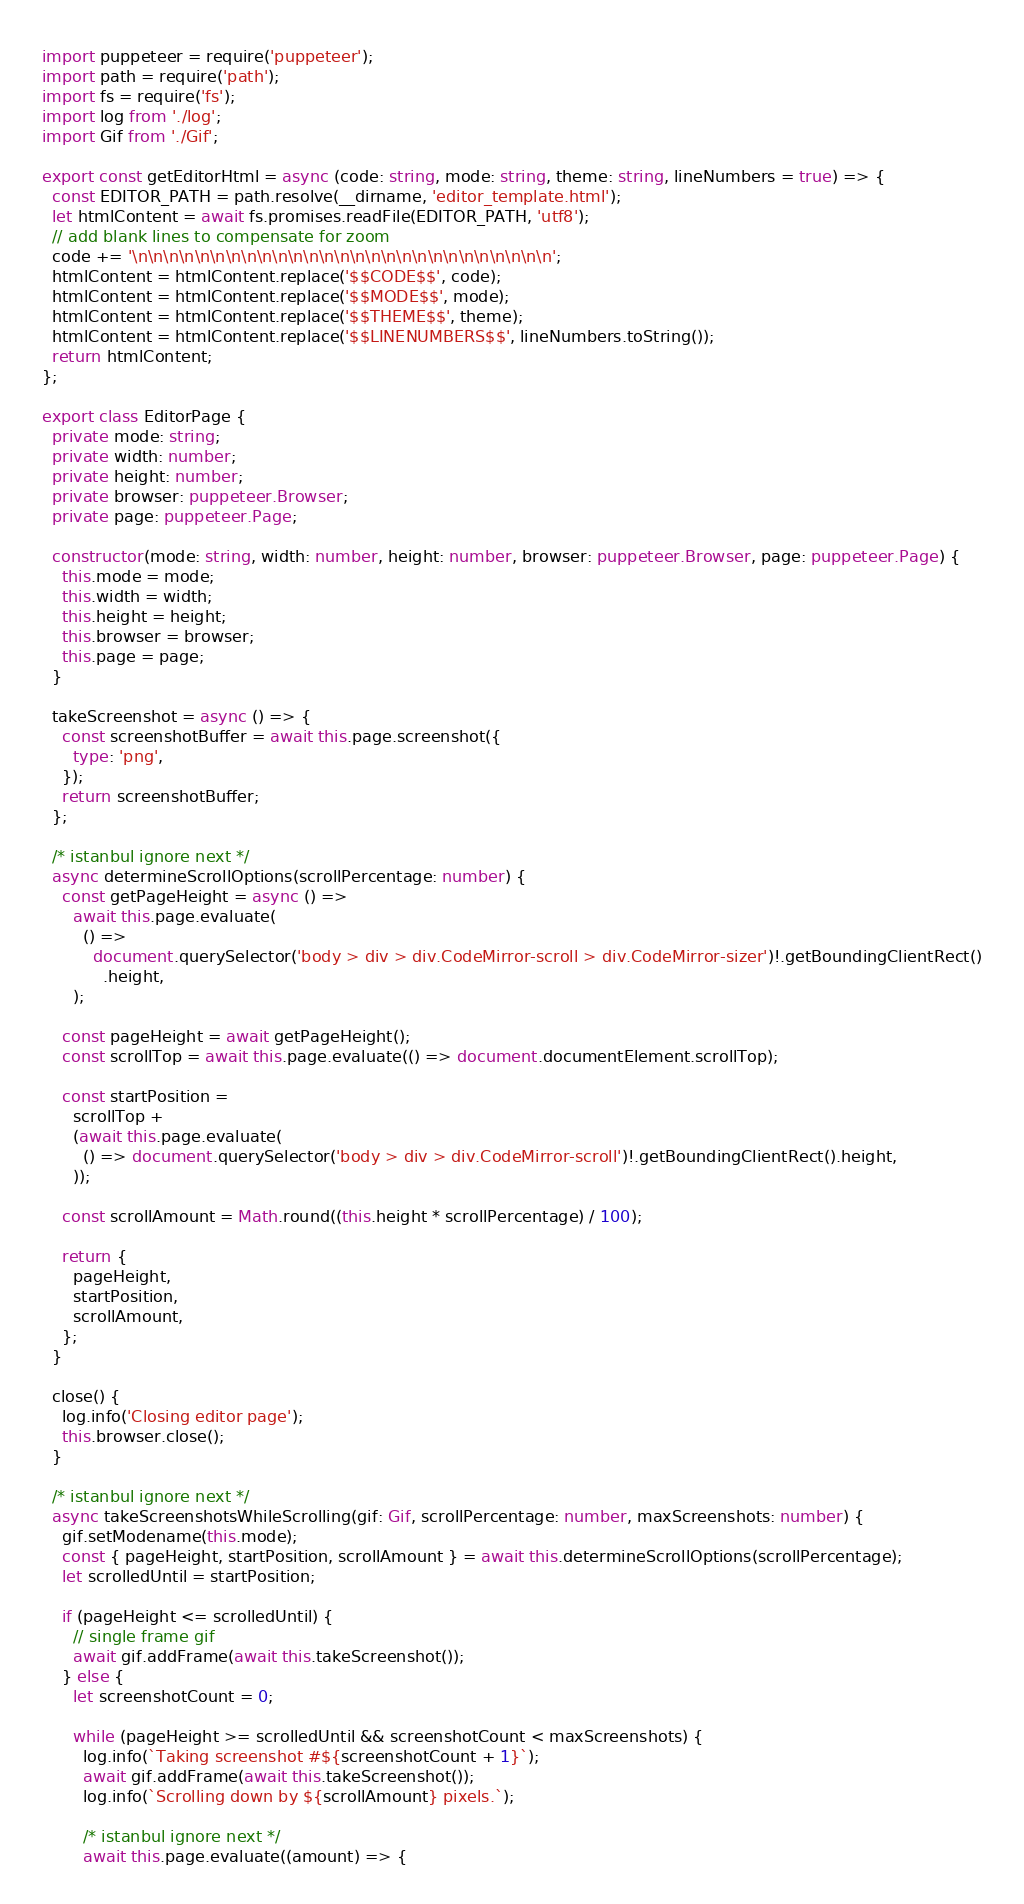<code> <loc_0><loc_0><loc_500><loc_500><_TypeScript_>import puppeteer = require('puppeteer');
import path = require('path');
import fs = require('fs');
import log from './log';
import Gif from './Gif';

export const getEditorHtml = async (code: string, mode: string, theme: string, lineNumbers = true) => {
  const EDITOR_PATH = path.resolve(__dirname, 'editor_template.html');
  let htmlContent = await fs.promises.readFile(EDITOR_PATH, 'utf8');
  // add blank lines to compensate for zoom
  code += '\n\n\n\n\n\n\n\n\n\n\n\n\n\n\n\n\n\n\n\n\n\n\n\n\n\n\n';
  htmlContent = htmlContent.replace('$$CODE$$', code);
  htmlContent = htmlContent.replace('$$MODE$$', mode);
  htmlContent = htmlContent.replace('$$THEME$$', theme);
  htmlContent = htmlContent.replace('$$LINENUMBERS$$', lineNumbers.toString());
  return htmlContent;
};

export class EditorPage {
  private mode: string;
  private width: number;
  private height: number;
  private browser: puppeteer.Browser;
  private page: puppeteer.Page;

  constructor(mode: string, width: number, height: number, browser: puppeteer.Browser, page: puppeteer.Page) {
    this.mode = mode;
    this.width = width;
    this.height = height;
    this.browser = browser;
    this.page = page;
  }

  takeScreenshot = async () => {
    const screenshotBuffer = await this.page.screenshot({
      type: 'png',
    });
    return screenshotBuffer;
  };

  /* istanbul ignore next */
  async determineScrollOptions(scrollPercentage: number) {
    const getPageHeight = async () =>
      await this.page.evaluate(
        () =>
          document.querySelector('body > div > div.CodeMirror-scroll > div.CodeMirror-sizer')!.getBoundingClientRect()
            .height,
      );

    const pageHeight = await getPageHeight();
    const scrollTop = await this.page.evaluate(() => document.documentElement.scrollTop);

    const startPosition =
      scrollTop +
      (await this.page.evaluate(
        () => document.querySelector('body > div > div.CodeMirror-scroll')!.getBoundingClientRect().height,
      ));

    const scrollAmount = Math.round((this.height * scrollPercentage) / 100);

    return {
      pageHeight,
      startPosition,
      scrollAmount,
    };
  }

  close() {
    log.info('Closing editor page');
    this.browser.close();
  }

  /* istanbul ignore next */
  async takeScreenshotsWhileScrolling(gif: Gif, scrollPercentage: number, maxScreenshots: number) {
    gif.setModename(this.mode);
    const { pageHeight, startPosition, scrollAmount } = await this.determineScrollOptions(scrollPercentage);
    let scrolledUntil = startPosition;

    if (pageHeight <= scrolledUntil) {
      // single frame gif
      await gif.addFrame(await this.takeScreenshot());
    } else {
      let screenshotCount = 0;

      while (pageHeight >= scrolledUntil && screenshotCount < maxScreenshots) {
        log.info(`Taking screenshot #${screenshotCount + 1}`);
        await gif.addFrame(await this.takeScreenshot());
        log.info(`Scrolling down by ${scrollAmount} pixels.`);

        /* istanbul ignore next */
        await this.page.evaluate((amount) => {</code> 